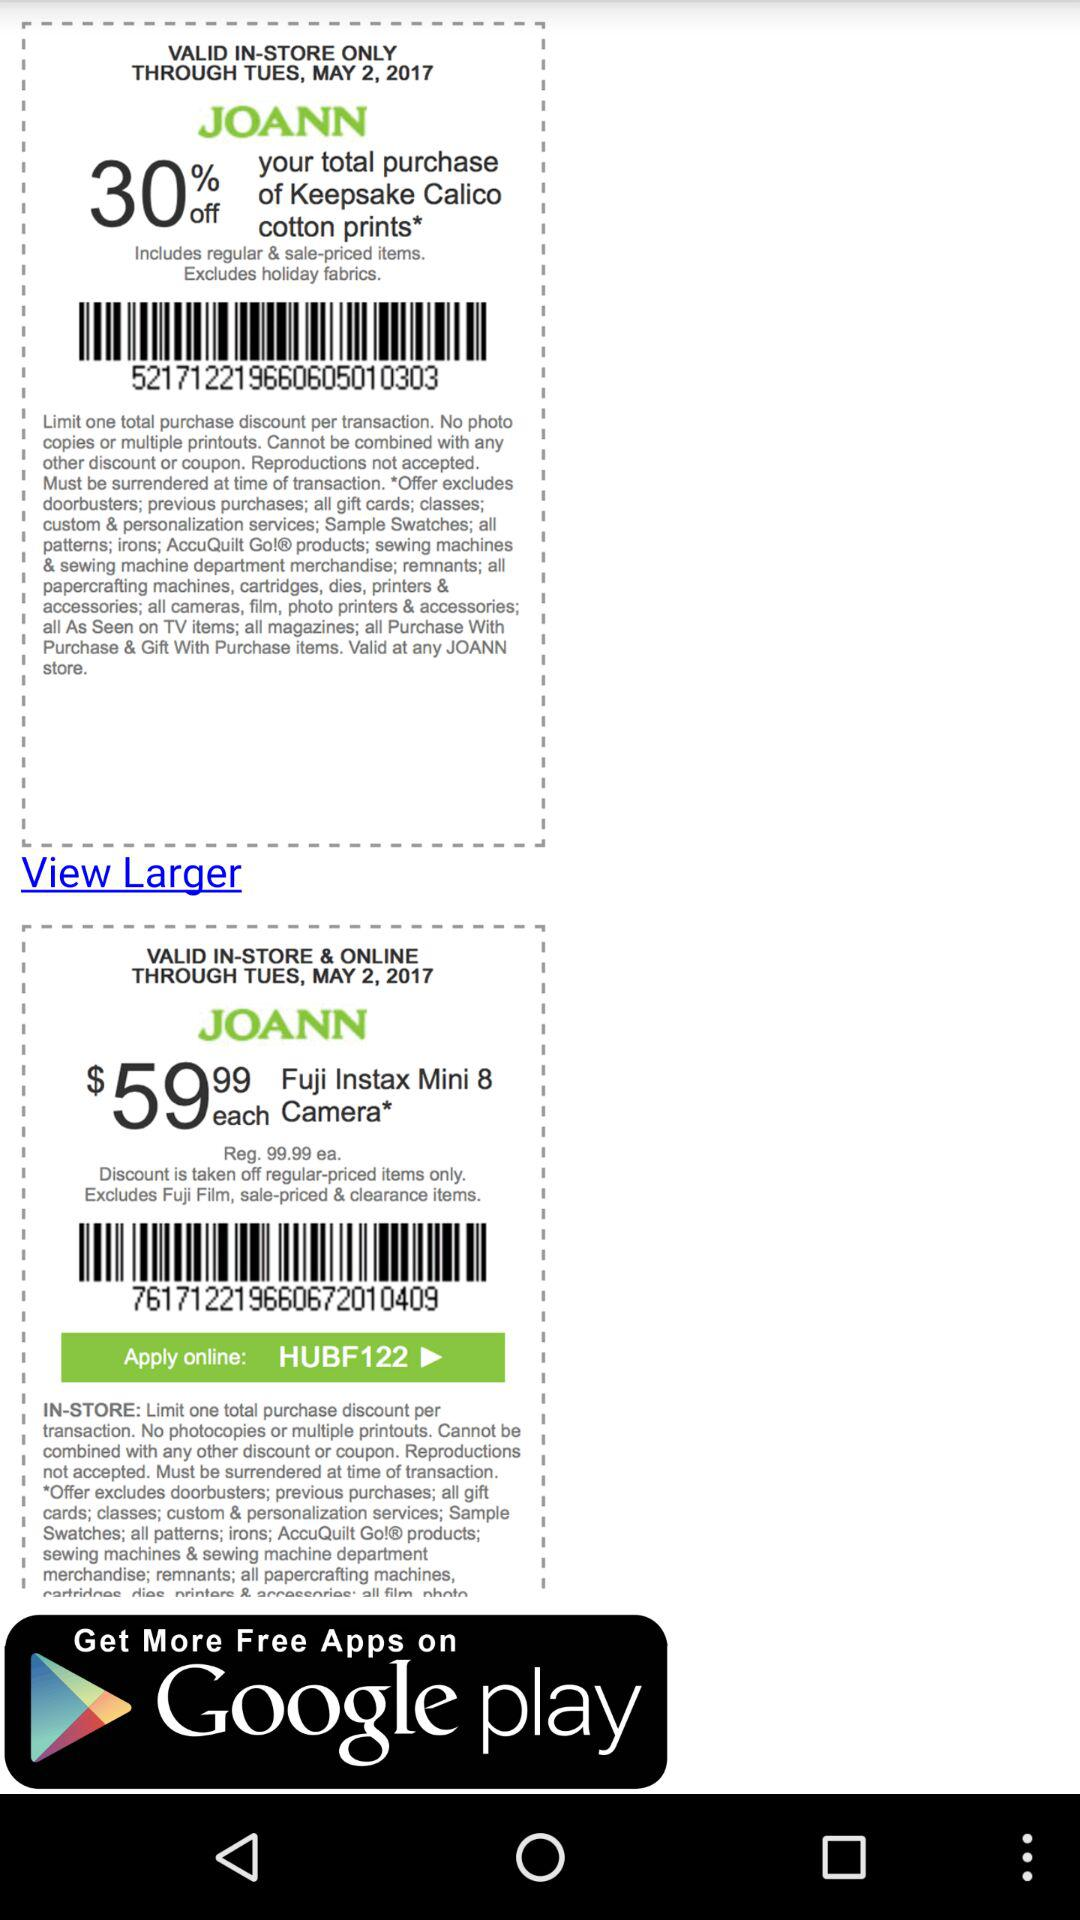How much is the discount? The discount is 30%. 